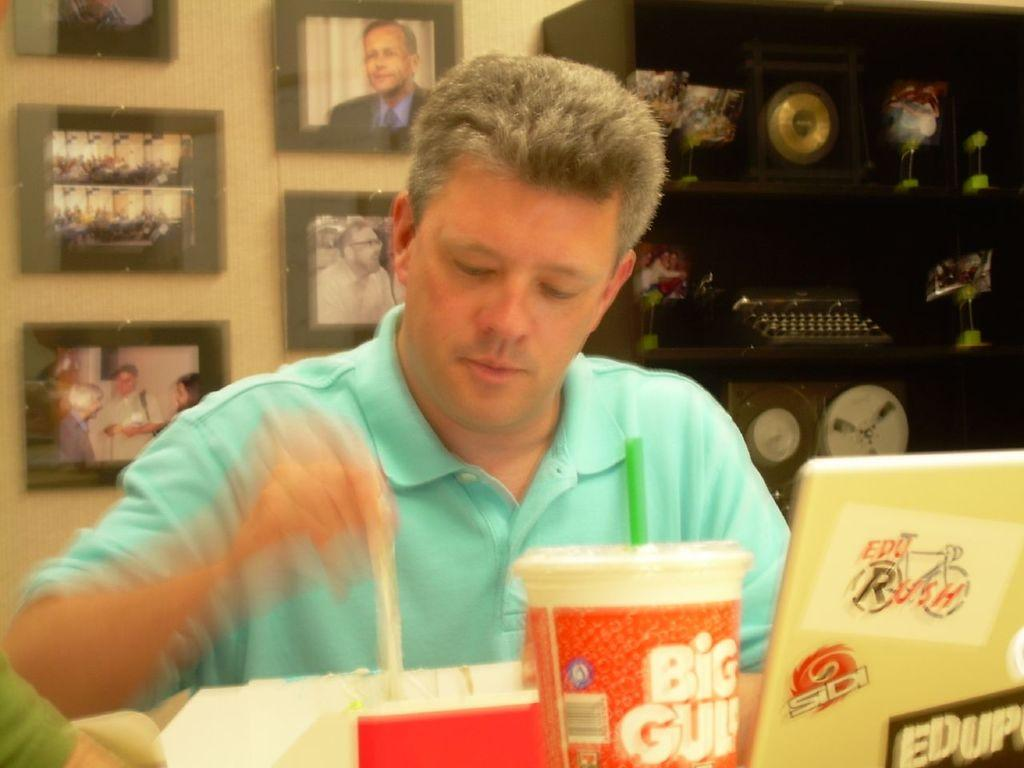<image>
Describe the image concisely. A man in a blue shirt is sitting at a table with a Big Gulp cup. 